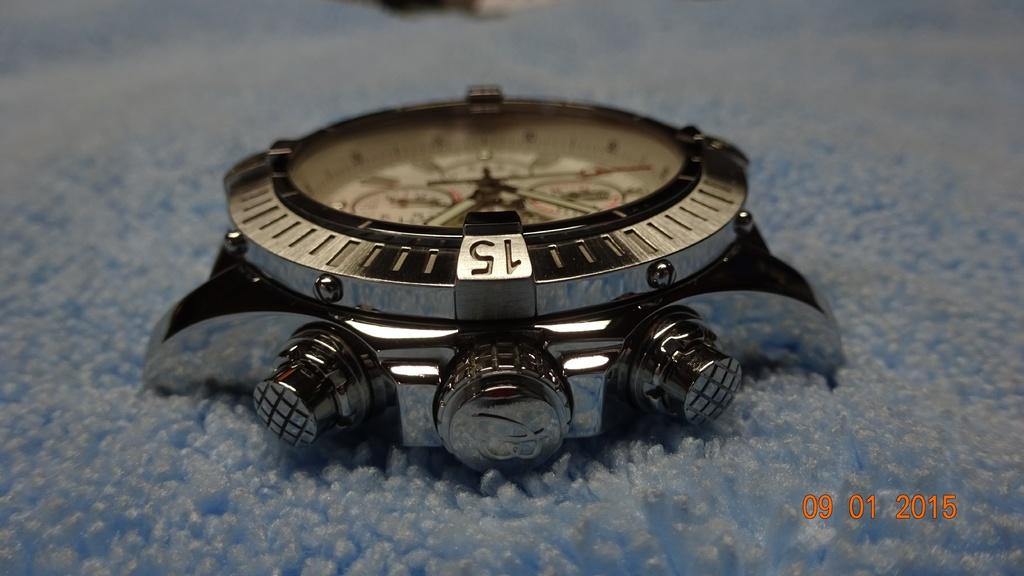<image>
Relay a brief, clear account of the picture shown. Face of a watch with the number 15 on one side. 